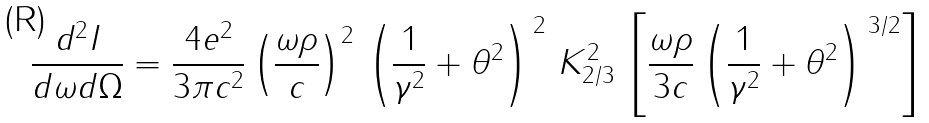<formula> <loc_0><loc_0><loc_500><loc_500>\frac { d ^ { 2 } I } { d \omega d \Omega } = \frac { 4 e ^ { 2 } } { 3 \pi c ^ { 2 } } \left ( \frac { \omega \rho } { c } \right ) ^ { 2 } \, \left ( \frac { 1 } { \gamma ^ { 2 } } + \theta ^ { 2 } \right ) ^ { \, 2 } \, K _ { 2 / 3 } ^ { 2 } \, \left [ \frac { \omega \rho } { 3 c } \left ( \frac { 1 } { \gamma ^ { 2 } } + \theta ^ { 2 } \right ) ^ { \, 3 / 2 } \right ]</formula> 